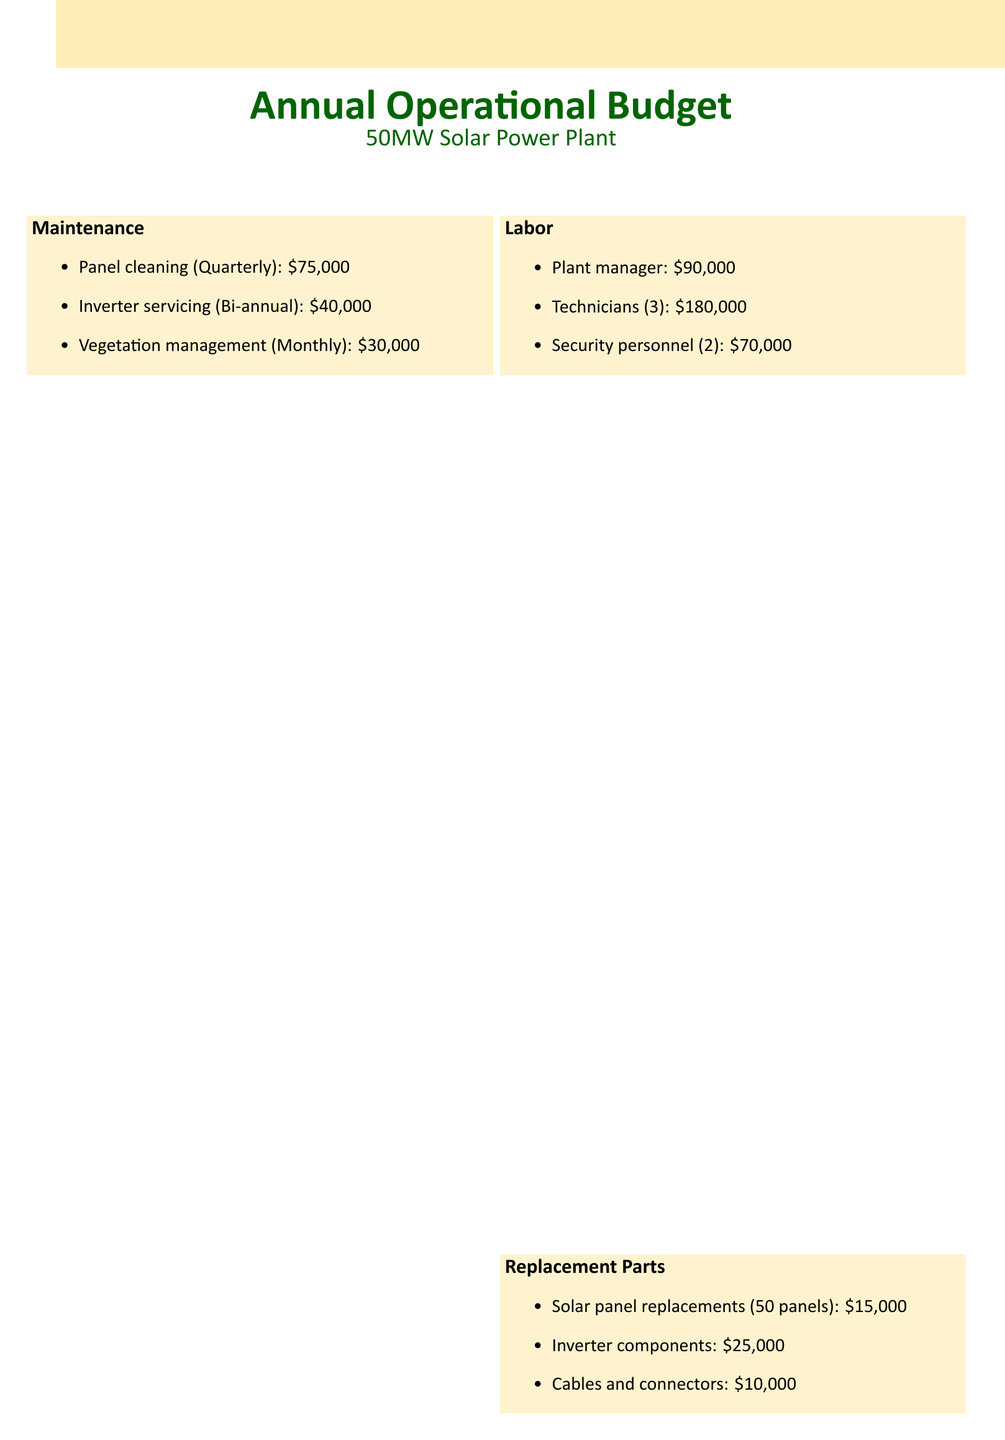what is the total annual operational expenses? The total annual operational expenses is stated in the document, totaling $735,000.
Answer: $735,000 how much is allocated for maintenance? The maintenance costs listed in the document can be summed up to determine the total allocation.
Answer: $145,000 how many technicians are employed? The document specifies that there are three technicians employed at the plant.
Answer: 3 what is the cost for inverter servicing? The document lists the cost for inverter servicing, which occurs bi-annually.
Answer: $40,000 how much is spent on grid connection fees? The grid connection fees amount is provided directly in the budget document.
Answer: $100,000 what is the monthly cost of vegetation management? The document specifies that vegetation management is a monthly expense costing $30,000.
Answer: $30,000 how many solar panels need replacement? The necessary replacements for solar panels are indicated in the document, specifying fifty panels.
Answer: 50 panels what is the combined cost of cables and connectors? The document provides a specific cost for cables and connectors as part of the replacement parts.
Answer: $10,000 how many security personnel are employed? The budget outlines staffing and indicates there are two security personnel on duty.
Answer: 2 